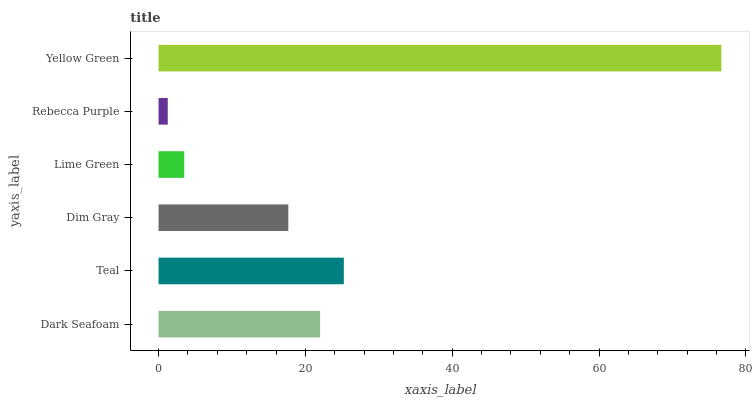Is Rebecca Purple the minimum?
Answer yes or no. Yes. Is Yellow Green the maximum?
Answer yes or no. Yes. Is Teal the minimum?
Answer yes or no. No. Is Teal the maximum?
Answer yes or no. No. Is Teal greater than Dark Seafoam?
Answer yes or no. Yes. Is Dark Seafoam less than Teal?
Answer yes or no. Yes. Is Dark Seafoam greater than Teal?
Answer yes or no. No. Is Teal less than Dark Seafoam?
Answer yes or no. No. Is Dark Seafoam the high median?
Answer yes or no. Yes. Is Dim Gray the low median?
Answer yes or no. Yes. Is Yellow Green the high median?
Answer yes or no. No. Is Lime Green the low median?
Answer yes or no. No. 